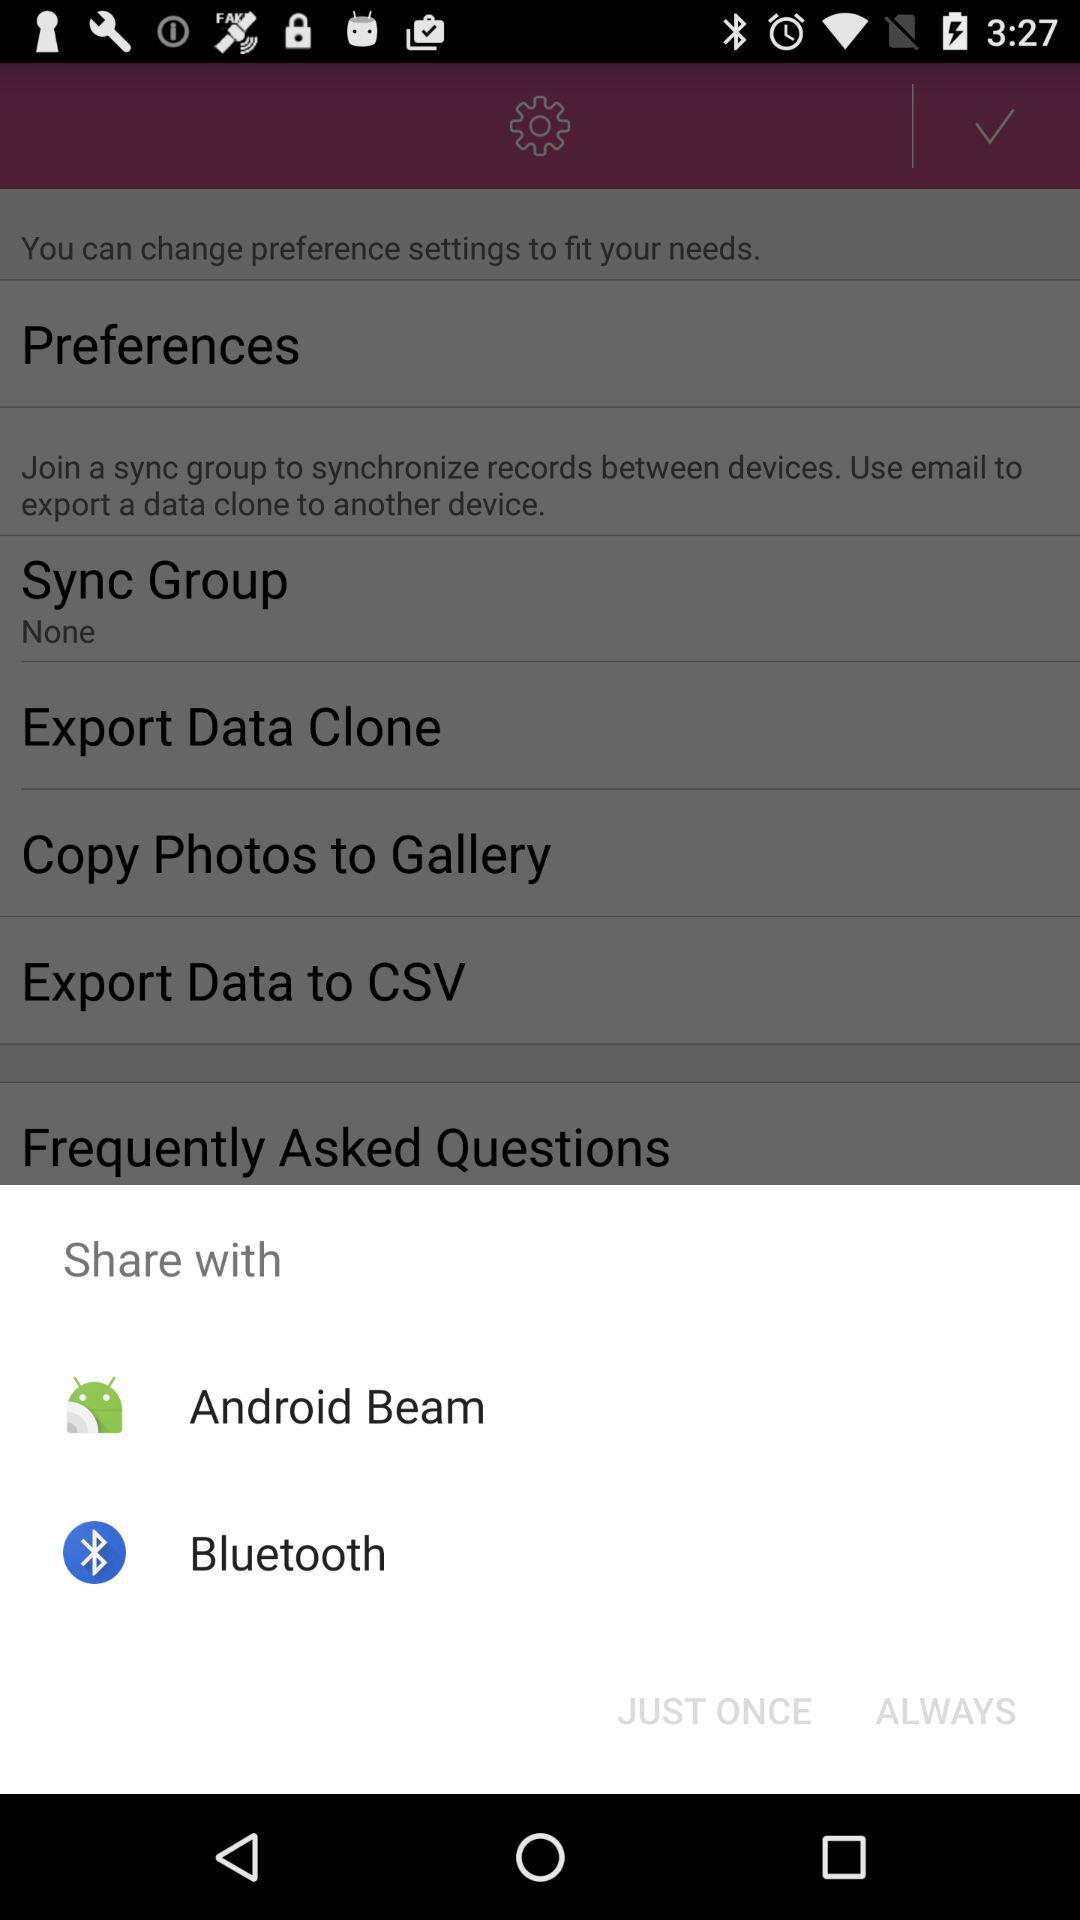What is the setting for "Sync Group"? The setting for "Sync Group" is "None". 